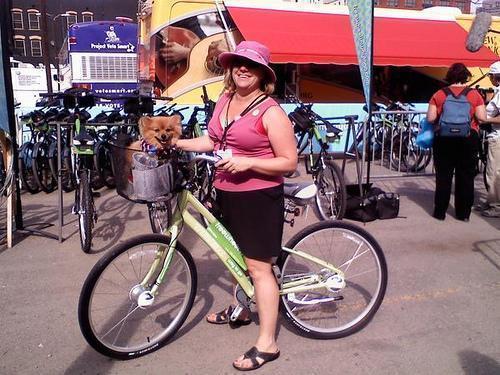Which wrong accessory has the woman worn for riding bike?
From the following four choices, select the correct answer to address the question.
Options: Shoes, hat, sunglasses, name tag. Shoes. What kind of accessory should the woman wear?
Make your selection from the four choices given to correctly answer the question.
Options: Scarf, wristbands, gloves, sports shoes. Sports shoes. 